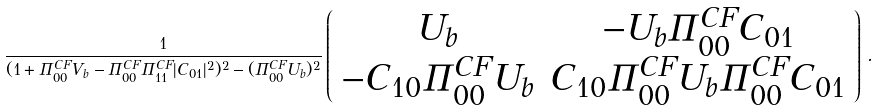Convert formula to latex. <formula><loc_0><loc_0><loc_500><loc_500>\frac { 1 } { ( 1 + \Pi ^ { C F } _ { 0 0 } V _ { b } - \Pi ^ { C F } _ { 0 0 } \Pi ^ { C F } _ { 1 1 } | C _ { 0 1 } | ^ { 2 } ) ^ { 2 } - ( \Pi ^ { C F } _ { 0 0 } U _ { b } ) ^ { 2 } } \left ( \begin{array} { c c } U _ { b } & - U _ { b } \Pi ^ { C F } _ { 0 0 } C _ { 0 1 } \\ - C _ { 1 0 } \Pi ^ { C F } _ { 0 0 } U _ { b } & C _ { 1 0 } \Pi ^ { C F } _ { 0 0 } U _ { b } \Pi ^ { C F } _ { 0 0 } C _ { 0 1 } \end{array} \right ) \, .</formula> 